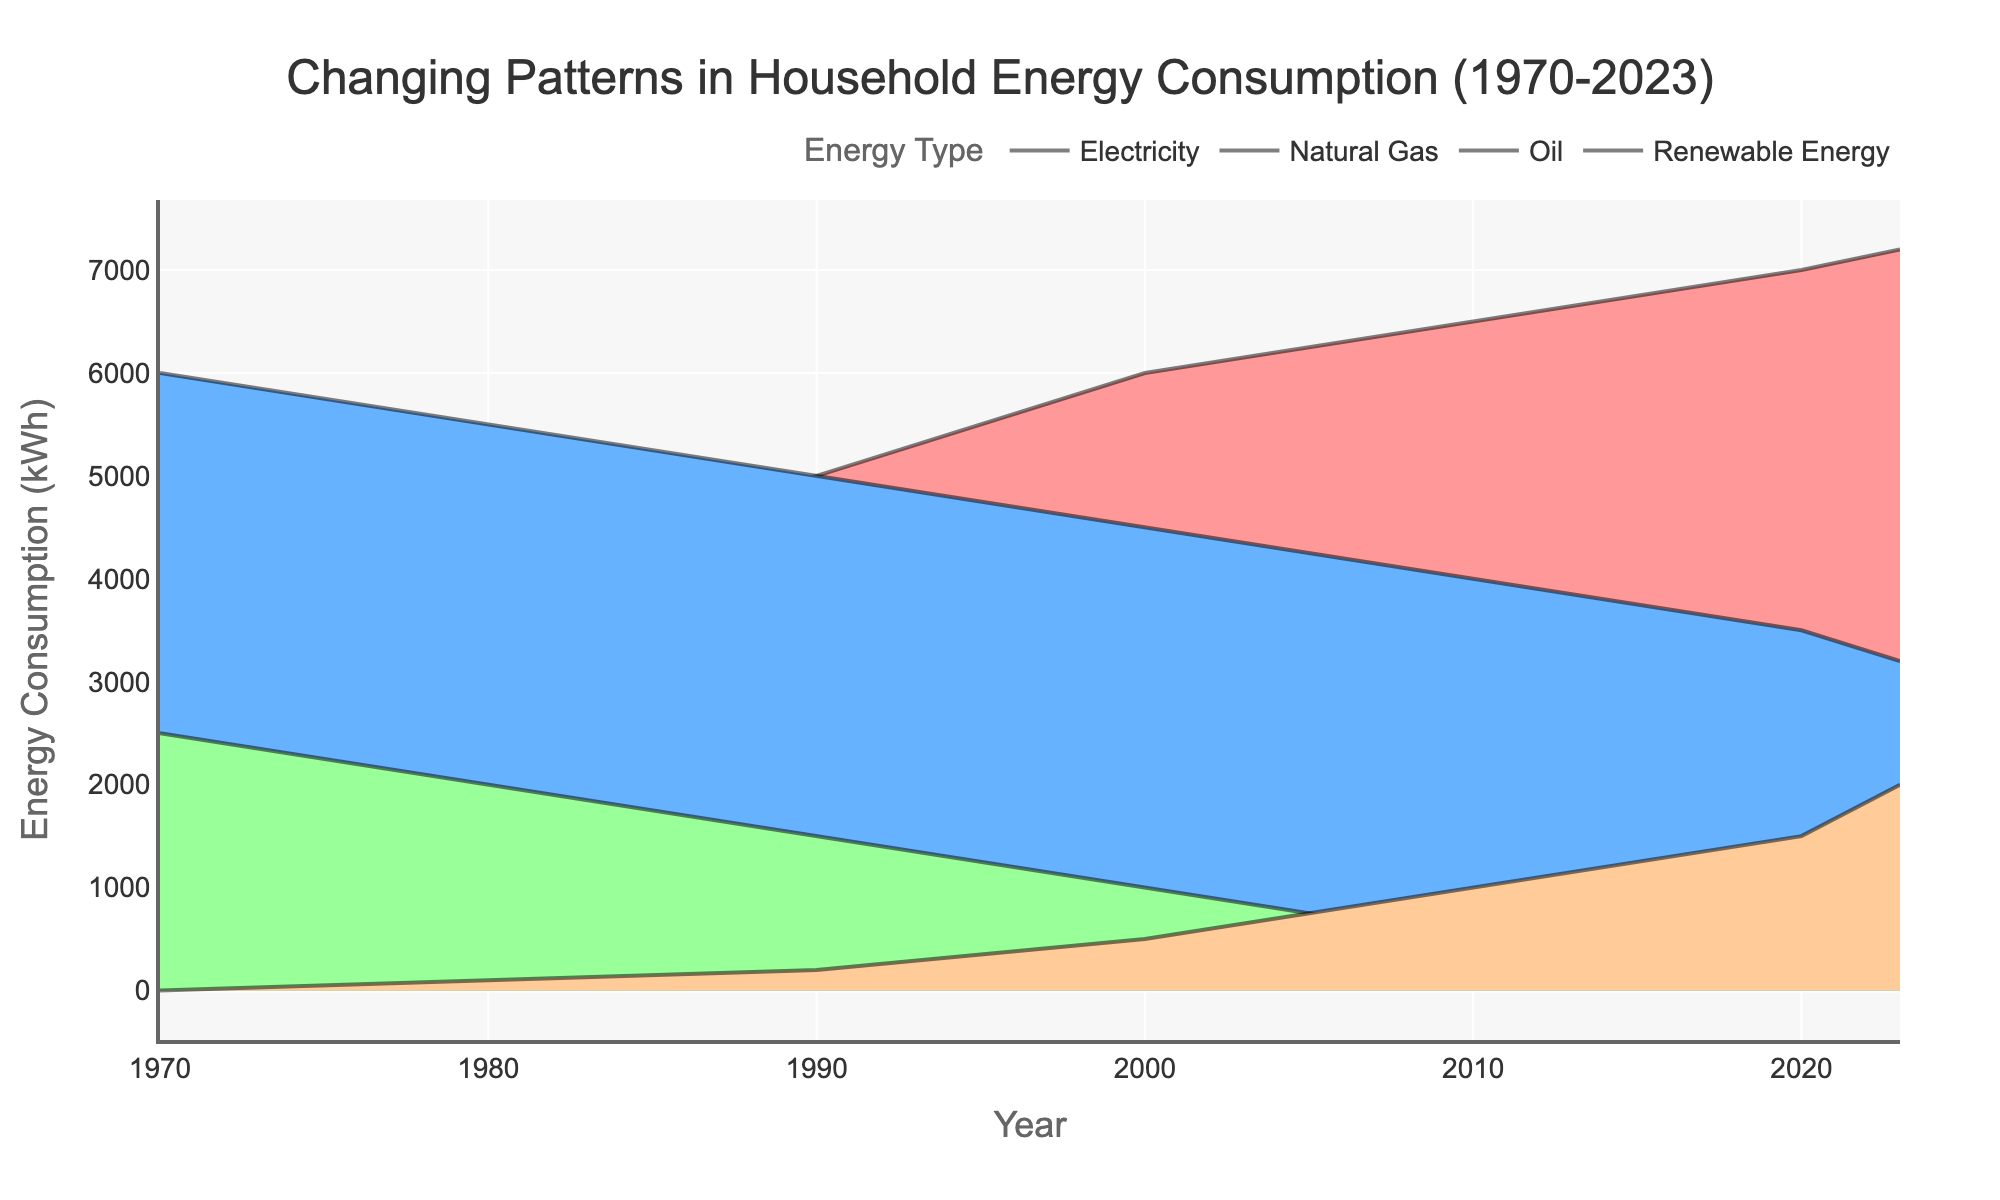What's the total energy consumption in the year 2000? The title of the figure mentions the total energy consumption over the years, and looking at the year 2000 in the figure helps us identify the total value.
Answer: 12000 kWh Which energy source saw the most significant increase from 1970 to 2023? Look at the trends for each energy source from 1970 to 2023. Electricity starts at 3500 kWh in 1970 and rises to 7200 kWh in 2023, indicating the most significant increase.
Answer: Electricity How did the consumption of Renewable Energy change from 1980 to 2023? In 1980, Renewable Energy consumption was 100 kWh, and it increased gradually to 2000 kWh by 2023. This shows a consistent increase.
Answer: Increased from 100 kWh to 2000 kWh What is the sum of energy consumption for Natural Gas and Oil in 1990? In 1990, Natural Gas consumption is 5000 kWh, and Oil consumption is 1500 kWh. Summing them up gives us 5000 + 1500.
Answer: 6500 kWh Which energy source saw a decrease in consumption over the period shown in the figure? Compare the starting and ending points of the consumption lines for each energy type. Natural Gas starts at 6000 kWh in 1970 and drops to 3200 kWh in 2023.
Answer: Natural Gas In which year did Renewable Energy consumption first reach 1000 kWh? Trace the Renewable Energy line in the plot. The first time it reaches 1000 kWh is in 2010.
Answer: 2010 Comparing 1970 and 2023, by how much has the total energy consumption increased? The total energy consumption in 1970 is 12000 kWh and in 2023 is 12500 kWh. The difference is 12500 - 12000.
Answer: 500 kWh Which energy source remained relatively stable in terms of consumption from 1970 to 2023? By examining the lines, Oil shows the most significant drop from 2500 kWh in 1970 to 100 kWh in 2023, but the consumption is relatively stable before the sharp decline after 2000.
Answer: Oil What trend is visible for the total energy consumption from the early 2000s to 2023? The total energy consumption remains quite steady around 12000 kWh from 2000 to 2023, with a slight increase towards 2023.
Answer: Remained stable with a slight increase 